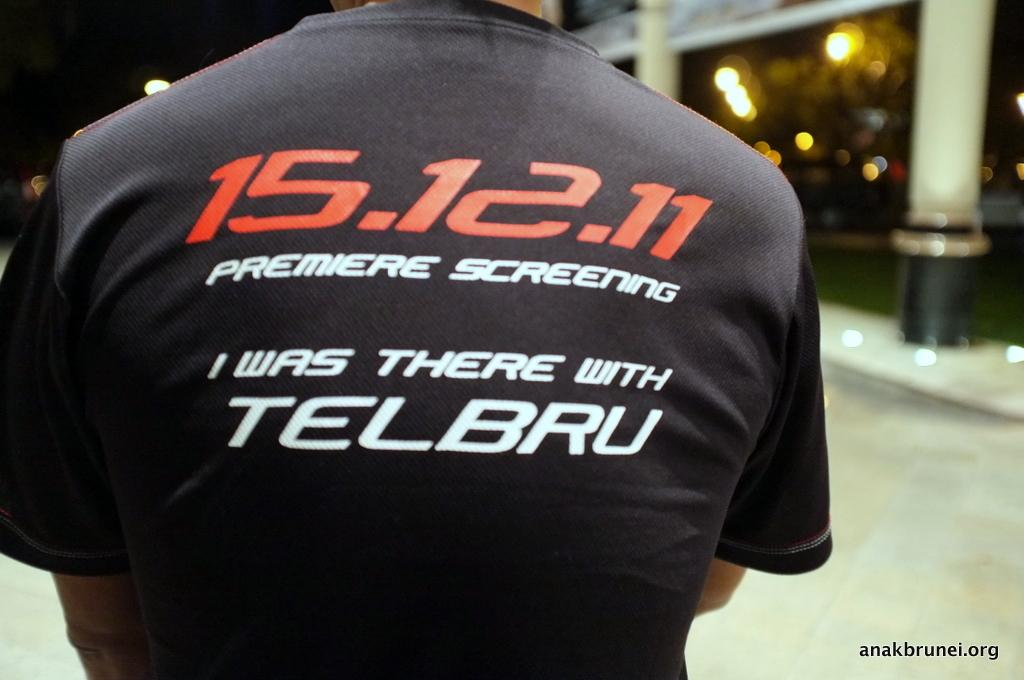<image>
Summarize the visual content of the image. A closeup of the back of a man's shirt which shows 15.12.11 Premiere Screening I was there with Telbru. 